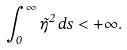<formula> <loc_0><loc_0><loc_500><loc_500>\int _ { 0 } ^ { \infty } \tilde { \eta } ^ { 2 } \, d s < + \infty .</formula> 